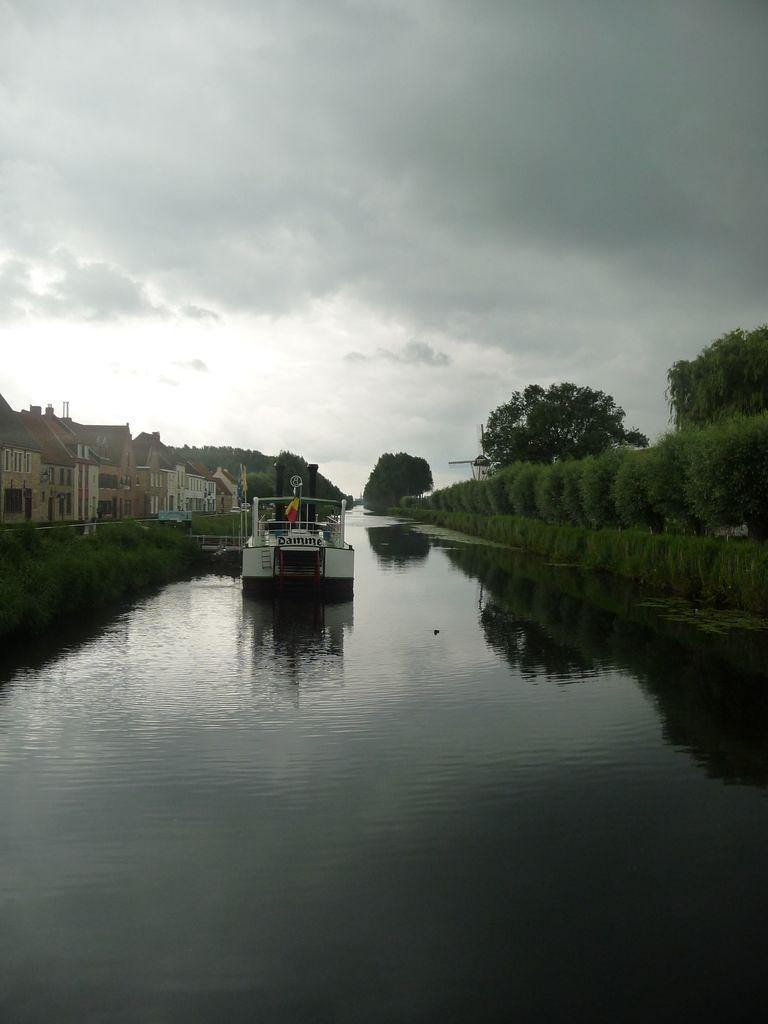What is the main subject of the image? The main subject of the image is a boat. What is the boat doing in the image? The boat is sailing on the water. What other structures can be seen in the image? There are houses in the image. What type of vegetation is present in the image? There are plants and trees in the image. What is visible in the background of the image? The sky is visible in the image, and there are clouds present. What can be observed about the water in the image? There is a reflection in the water. What type of stamp can be seen on the boat in the image? There is no stamp present on the boat in the image. What emotion does the boat exhibit in the image? Boats do not exhibit emotions, as they are inanimate objects. 